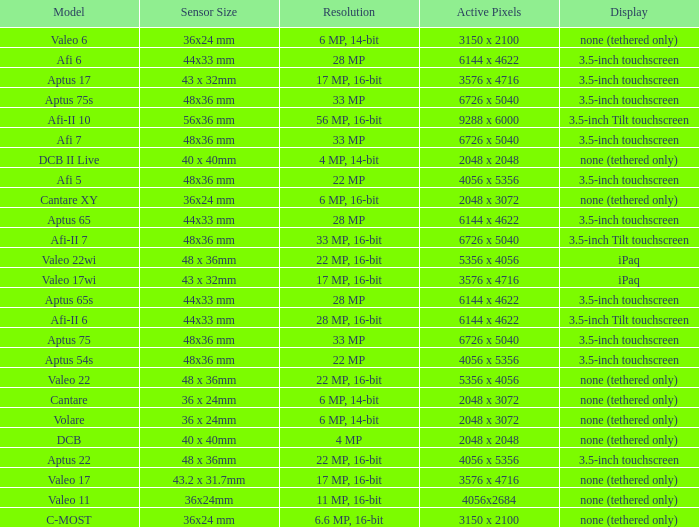What are the active pixels of the cantare model? 2048 x 3072. 